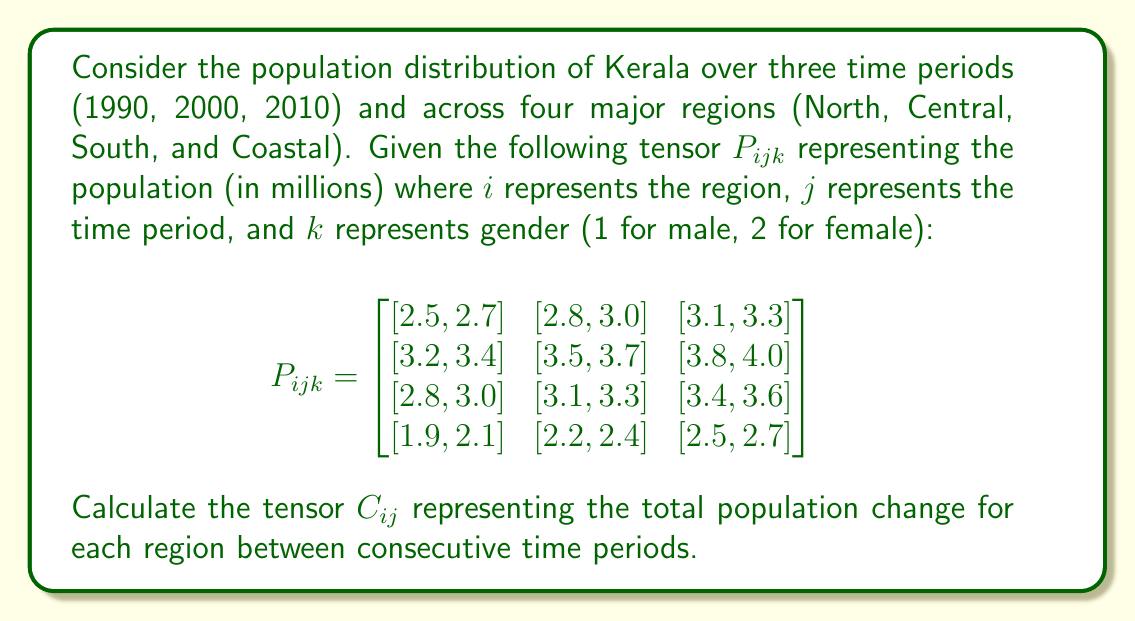Teach me how to tackle this problem. To solve this problem, we need to follow these steps:

1) First, we need to calculate the total population for each region and time period by summing the male and female populations.

2) Then, we calculate the change in population between consecutive time periods for each region.

3) Finally, we construct the tensor $C_{ij}$ representing these changes.

Step 1: Calculate total population for each region and time period

For each element in $P_{ijk}$, we sum across the third dimension (k) to get the total population:

$$T_{ij} = \sum_k P_{ijk}$$

This gives us:

$$T_{ij} = \begin{bmatrix}
5.2 & 5.8 & 6.4 \\
6.6 & 7.2 & 7.8 \\
5.8 & 6.4 & 7.0 \\
4.0 & 4.6 & 5.2
\end{bmatrix}$$

Step 2: Calculate population change between consecutive time periods

For each region, we calculate the change from 1990 to 2000 and from 2000 to 2010:

North: 5.8 - 5.2 = 0.6, 6.4 - 5.8 = 0.6
Central: 7.2 - 6.6 = 0.6, 7.8 - 7.2 = 0.6
South: 6.4 - 5.8 = 0.6, 7.0 - 6.4 = 0.6
Coastal: 4.6 - 4.0 = 0.6, 5.2 - 4.6 = 0.6

Step 3: Construct the tensor $C_{ij}$

The tensor $C_{ij}$ will have dimensions 4x2, where the rows represent the four regions and the columns represent the two time period changes:

$$C_{ij} = \begin{bmatrix}
0.6 & 0.6 \\
0.6 & 0.6 \\
0.6 & 0.6 \\
0.6 & 0.6
\end{bmatrix}$$
Answer: $$C_{ij} = \begin{bmatrix}
0.6 & 0.6 \\
0.6 & 0.6 \\
0.6 & 0.6 \\
0.6 & 0.6
\end{bmatrix}$$ 